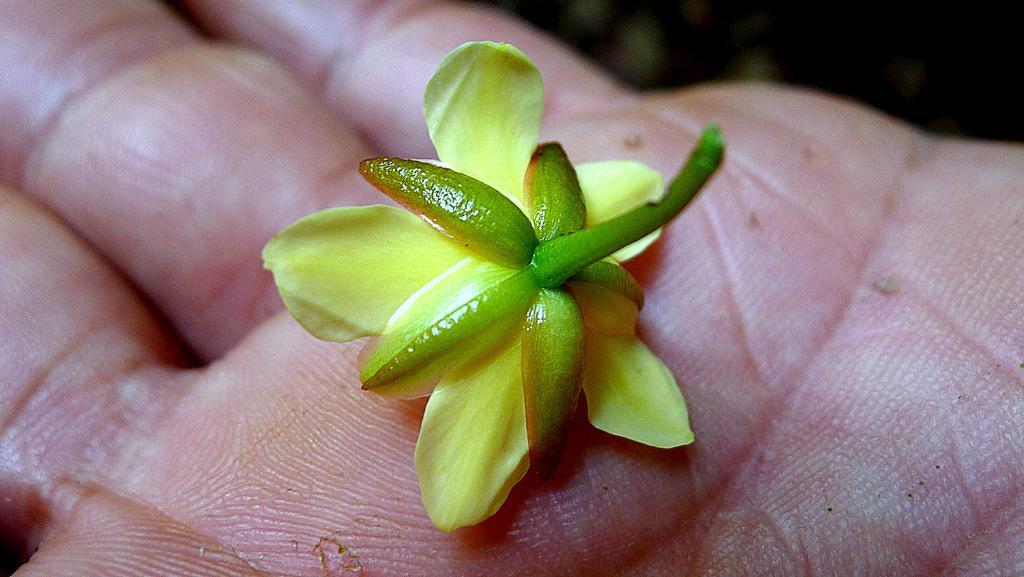Please provide a concise description of this image. The picture consists of a flower on a person's hand. At the top it is blurred. 